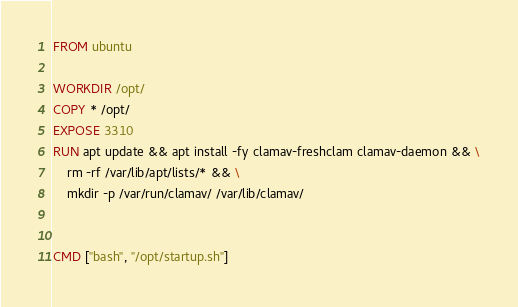Convert code to text. <code><loc_0><loc_0><loc_500><loc_500><_Dockerfile_>FROM ubuntu

WORKDIR /opt/
COPY * /opt/
EXPOSE 3310
RUN apt update && apt install -fy clamav-freshclam clamav-daemon && \
    rm -rf /var/lib/apt/lists/* && \
    mkdir -p /var/run/clamav/ /var/lib/clamav/


CMD ["bash", "/opt/startup.sh"]
</code> 